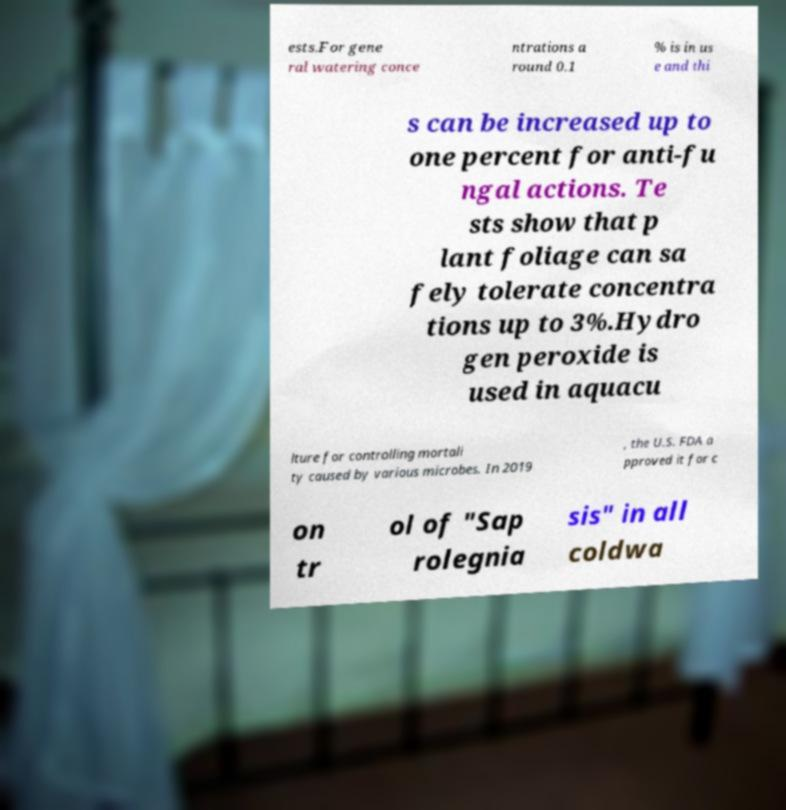For documentation purposes, I need the text within this image transcribed. Could you provide that? ests.For gene ral watering conce ntrations a round 0.1 % is in us e and thi s can be increased up to one percent for anti-fu ngal actions. Te sts show that p lant foliage can sa fely tolerate concentra tions up to 3%.Hydro gen peroxide is used in aquacu lture for controlling mortali ty caused by various microbes. In 2019 , the U.S. FDA a pproved it for c on tr ol of "Sap rolegnia sis" in all coldwa 